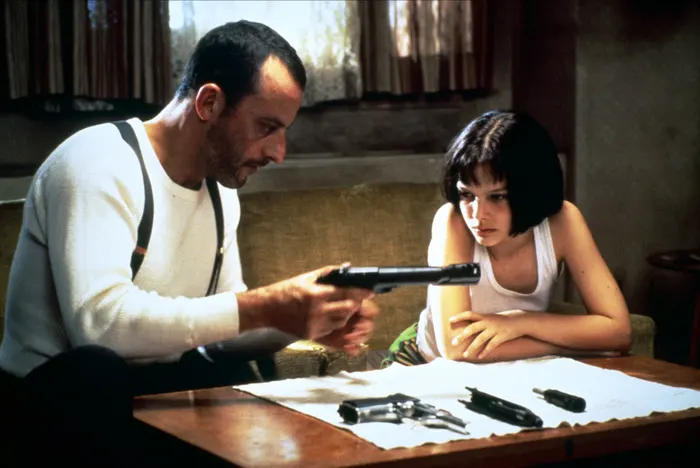What emotions are conveyed in this image and how do they contribute to the narrative? The image conveys a sense of tension, concentration, and urgency. Léon's focused expression as he handles the gun suggests his dedication to a task that requires precision, possibly training or preparing for a mission. Mathilda's concerned gaze indicates her emotional turmoil and growing involvement in Léon's dangerous world. These emotions add depth to the narrative, showcasing the complexity of their relationship and the high stakes of their situation. 